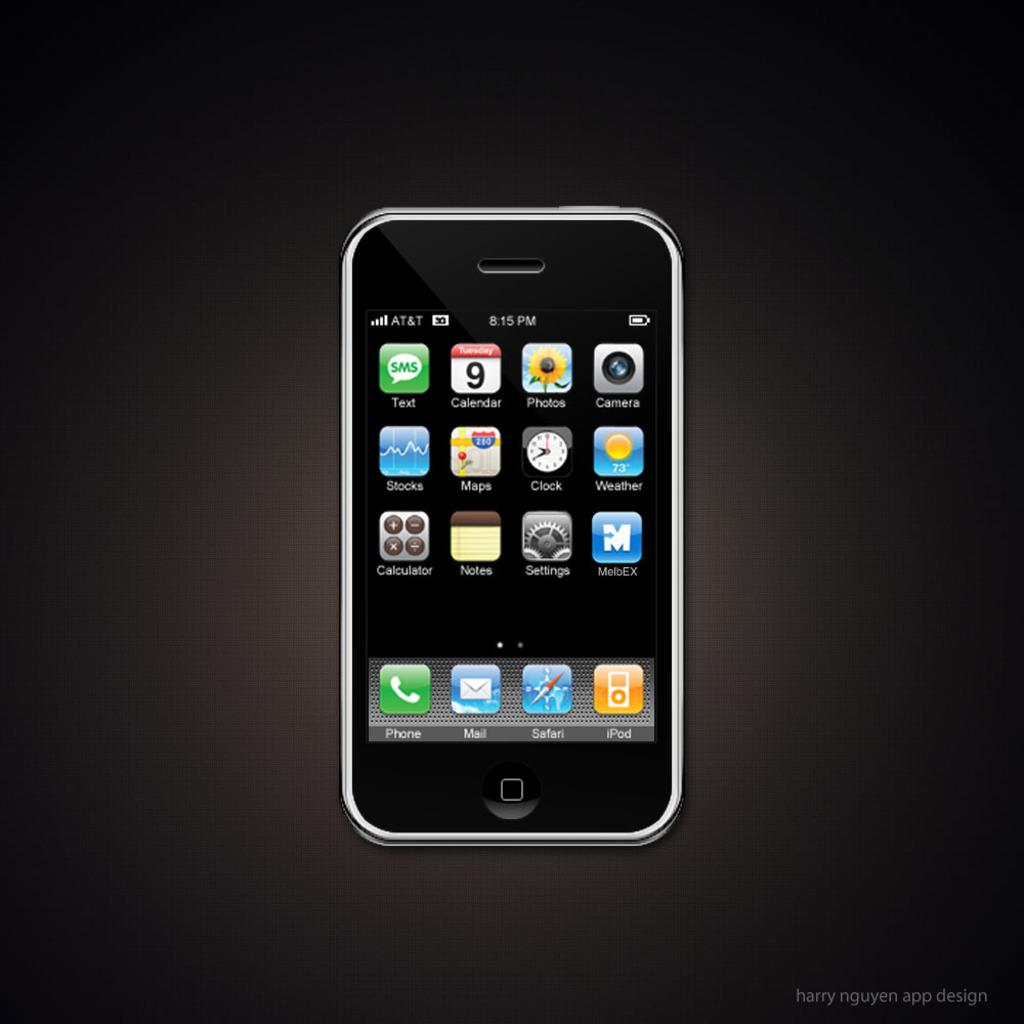<image>
Give a short and clear explanation of the subsequent image. An AT&T smart phone open to a page full of apps. 